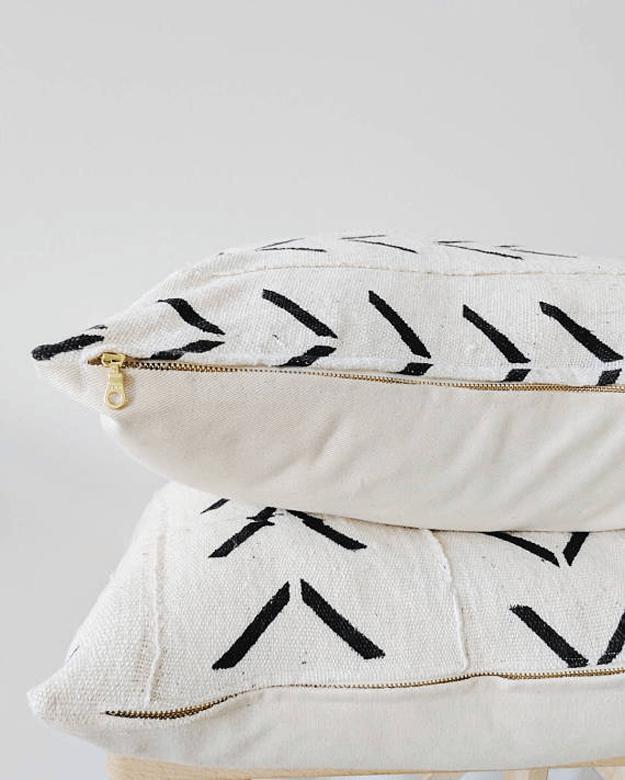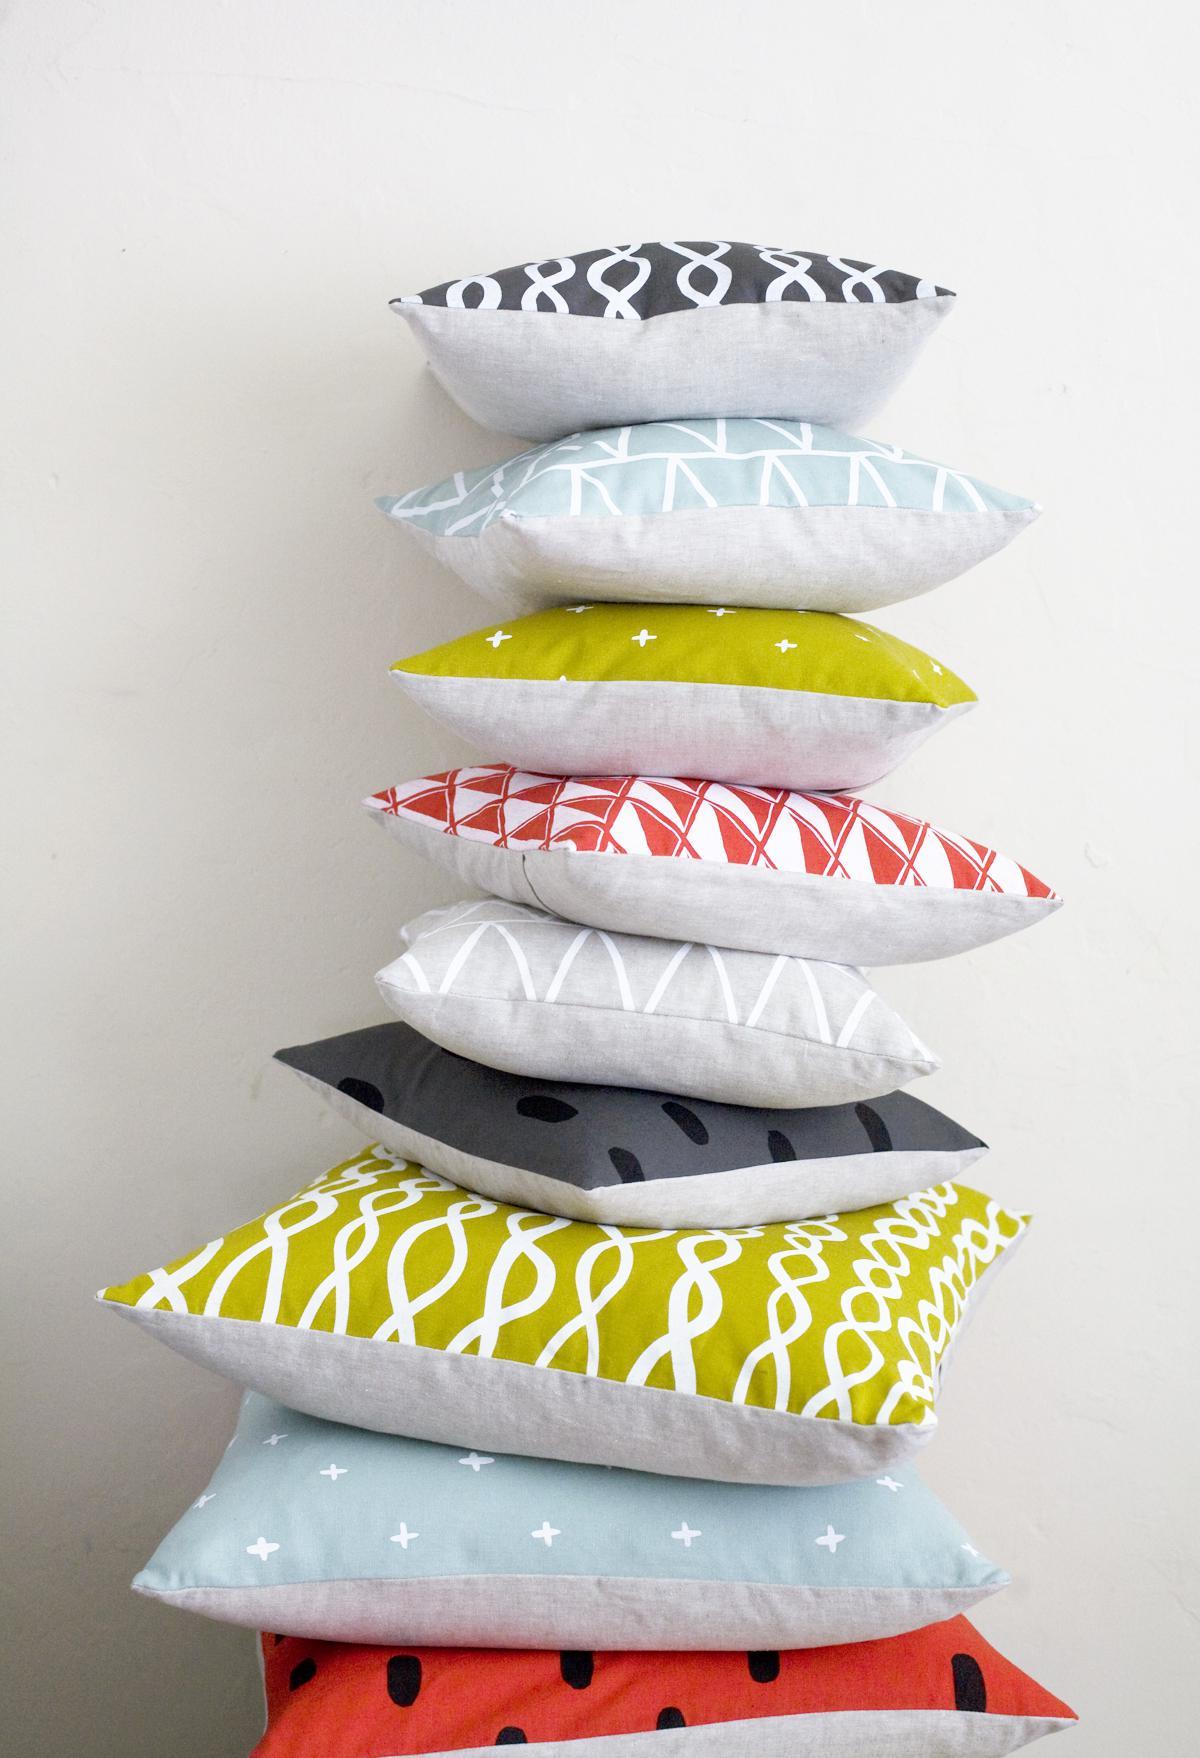The first image is the image on the left, the second image is the image on the right. For the images displayed, is the sentence "One of the stacks has exactly three pillows and is decorated with ribbons and flowers." factually correct? Answer yes or no. No. 